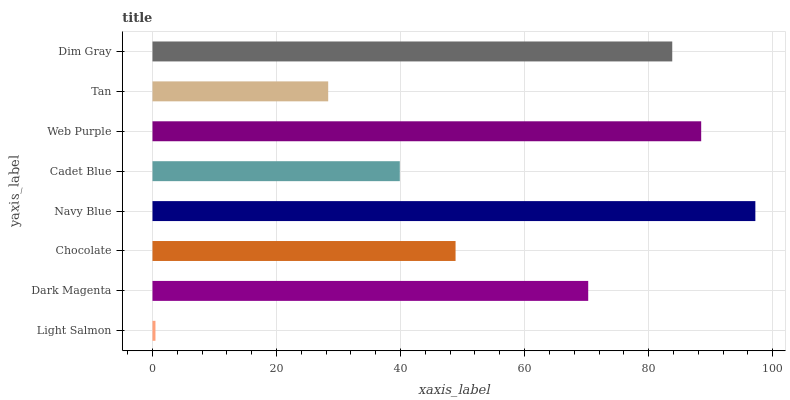Is Light Salmon the minimum?
Answer yes or no. Yes. Is Navy Blue the maximum?
Answer yes or no. Yes. Is Dark Magenta the minimum?
Answer yes or no. No. Is Dark Magenta the maximum?
Answer yes or no. No. Is Dark Magenta greater than Light Salmon?
Answer yes or no. Yes. Is Light Salmon less than Dark Magenta?
Answer yes or no. Yes. Is Light Salmon greater than Dark Magenta?
Answer yes or no. No. Is Dark Magenta less than Light Salmon?
Answer yes or no. No. Is Dark Magenta the high median?
Answer yes or no. Yes. Is Chocolate the low median?
Answer yes or no. Yes. Is Dim Gray the high median?
Answer yes or no. No. Is Web Purple the low median?
Answer yes or no. No. 